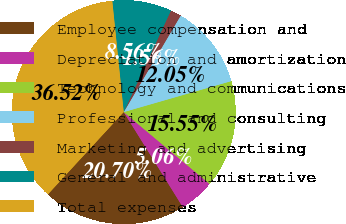Convert chart to OTSL. <chart><loc_0><loc_0><loc_500><loc_500><pie_chart><fcel>Employee compensation and<fcel>Depreciation and amortization<fcel>Technology and communications<fcel>Professional and consulting<fcel>Marketing and advertising<fcel>General and administrative<fcel>Total expenses<nl><fcel>20.7%<fcel>5.06%<fcel>15.55%<fcel>12.05%<fcel>1.56%<fcel>8.56%<fcel>36.52%<nl></chart> 